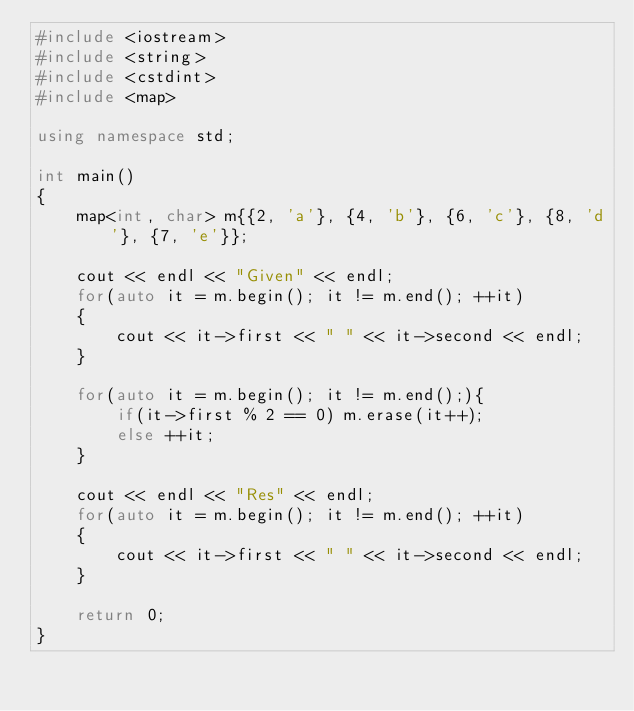<code> <loc_0><loc_0><loc_500><loc_500><_C++_>#include <iostream>
#include <string>
#include <cstdint>
#include <map>

using namespace std;

int main()
{
    map<int, char> m{{2, 'a'}, {4, 'b'}, {6, 'c'}, {8, 'd'}, {7, 'e'}};

    cout << endl << "Given" << endl;
    for(auto it = m.begin(); it != m.end(); ++it)
    {
        cout << it->first << " " << it->second << endl;
    }

    for(auto it = m.begin(); it != m.end();){
        if(it->first % 2 == 0) m.erase(it++);
        else ++it;
    }

    cout << endl << "Res" << endl;
    for(auto it = m.begin(); it != m.end(); ++it)
    {
        cout << it->first << " " << it->second << endl;
    }

    return 0;
}
</code> 